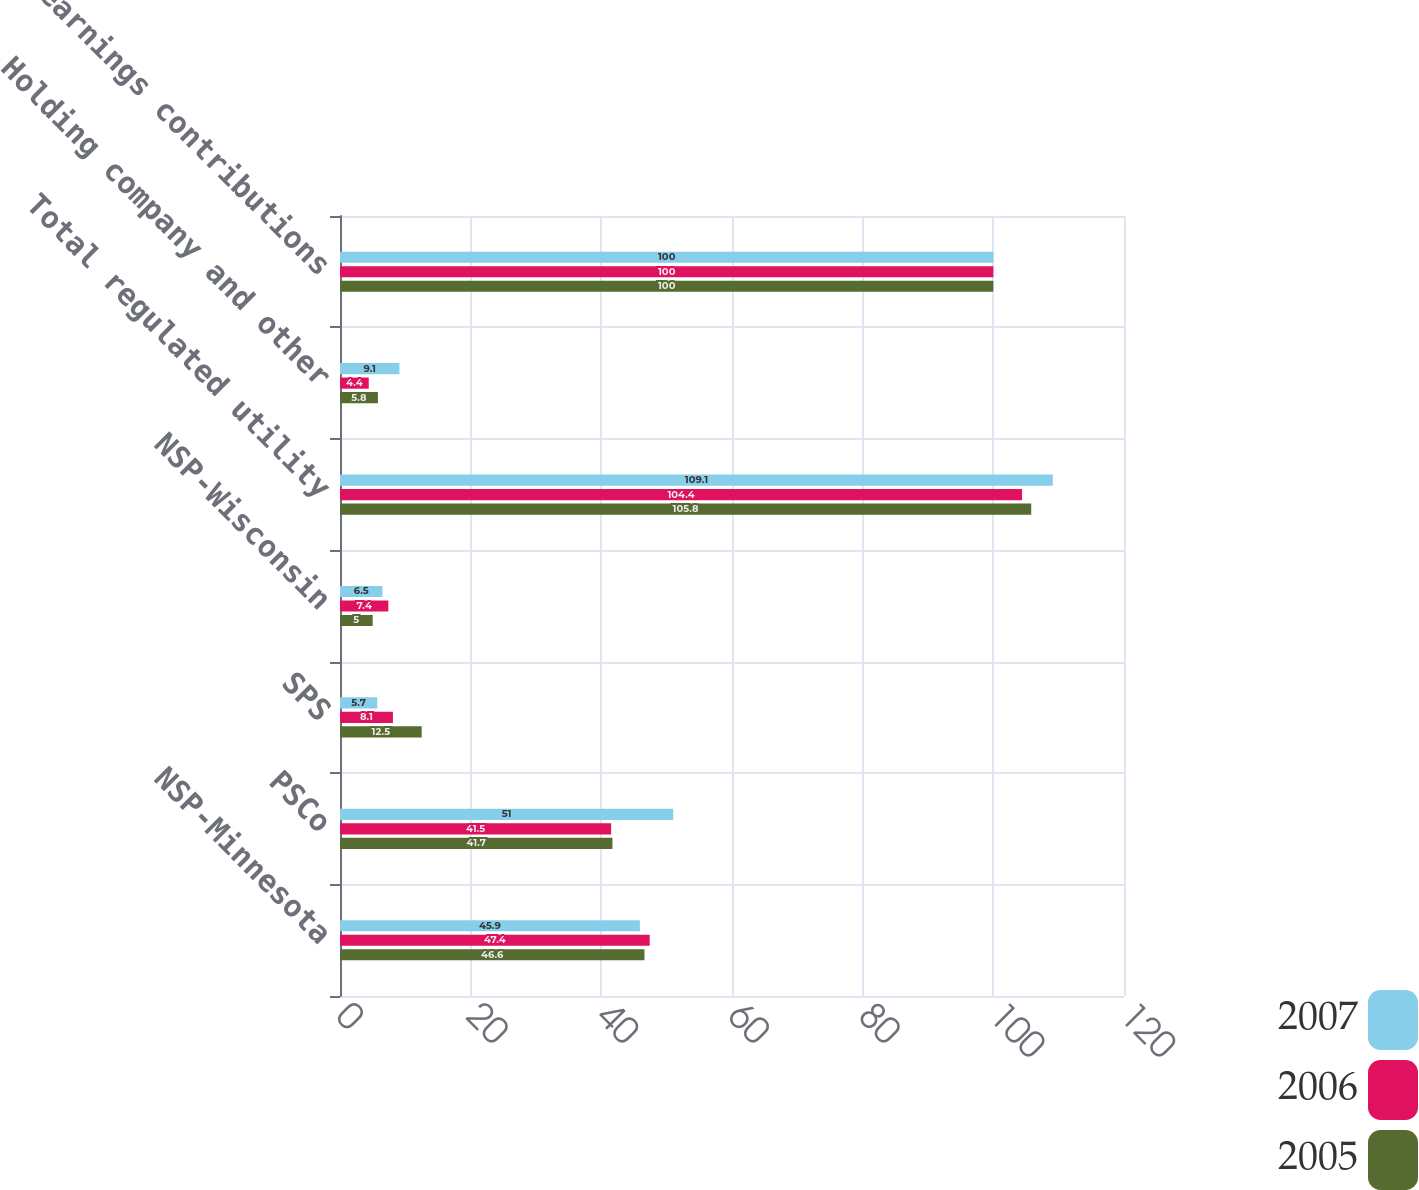<chart> <loc_0><loc_0><loc_500><loc_500><stacked_bar_chart><ecel><fcel>NSP-Minnesota<fcel>PSCo<fcel>SPS<fcel>NSP-Wisconsin<fcel>Total regulated utility<fcel>Holding company and other<fcel>Total earnings contributions<nl><fcel>2007<fcel>45.9<fcel>51<fcel>5.7<fcel>6.5<fcel>109.1<fcel>9.1<fcel>100<nl><fcel>2006<fcel>47.4<fcel>41.5<fcel>8.1<fcel>7.4<fcel>104.4<fcel>4.4<fcel>100<nl><fcel>2005<fcel>46.6<fcel>41.7<fcel>12.5<fcel>5<fcel>105.8<fcel>5.8<fcel>100<nl></chart> 